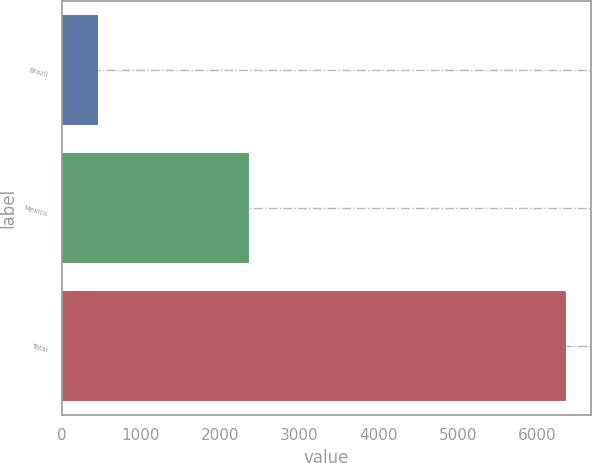Convert chart to OTSL. <chart><loc_0><loc_0><loc_500><loc_500><bar_chart><fcel>Brazil<fcel>Mexico<fcel>Total<nl><fcel>465<fcel>2358<fcel>6360<nl></chart> 